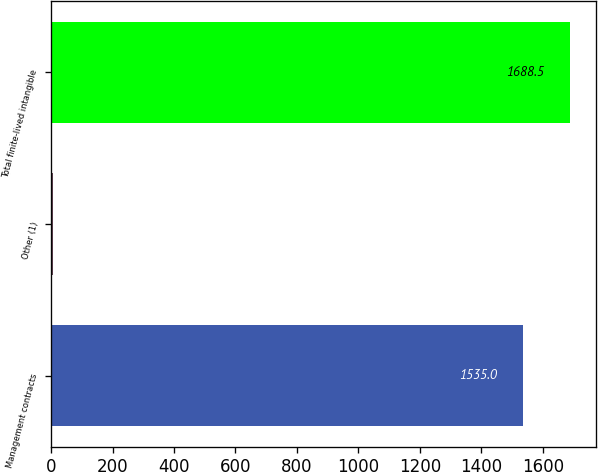Convert chart. <chart><loc_0><loc_0><loc_500><loc_500><bar_chart><fcel>Management contracts<fcel>Other (1)<fcel>Total finite-lived intangible<nl><fcel>1535<fcel>6<fcel>1688.5<nl></chart> 